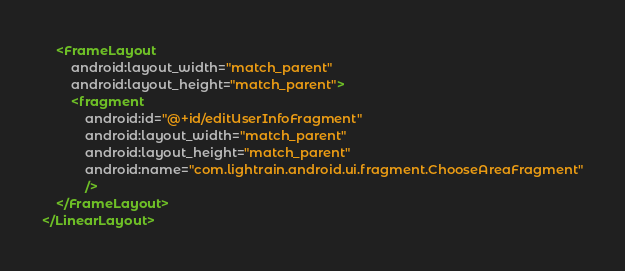<code> <loc_0><loc_0><loc_500><loc_500><_XML_>    <FrameLayout
        android:layout_width="match_parent"
        android:layout_height="match_parent">
        <fragment
            android:id="@+id/editUserInfoFragment"
            android:layout_width="match_parent"
            android:layout_height="match_parent"
            android:name="com.lightrain.android.ui.fragment.ChooseAreaFragment"
            />
    </FrameLayout>
</LinearLayout></code> 